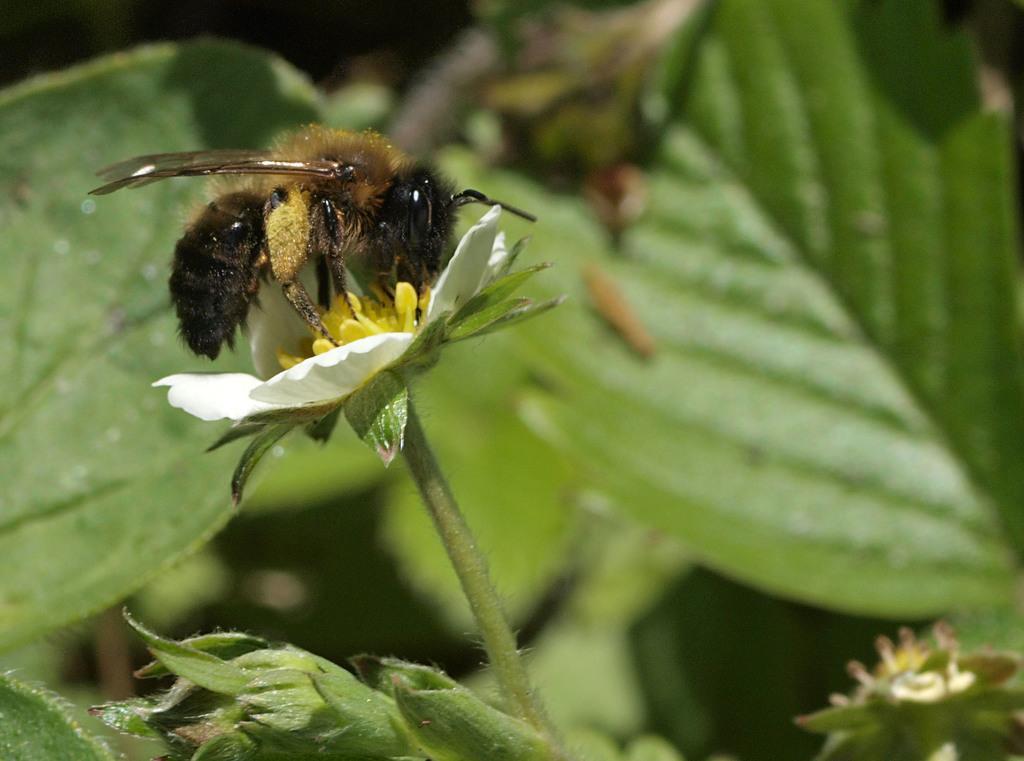In one or two sentences, can you explain what this image depicts? In this image I can see an insect on the flower. In the background, I can see the leaves. 